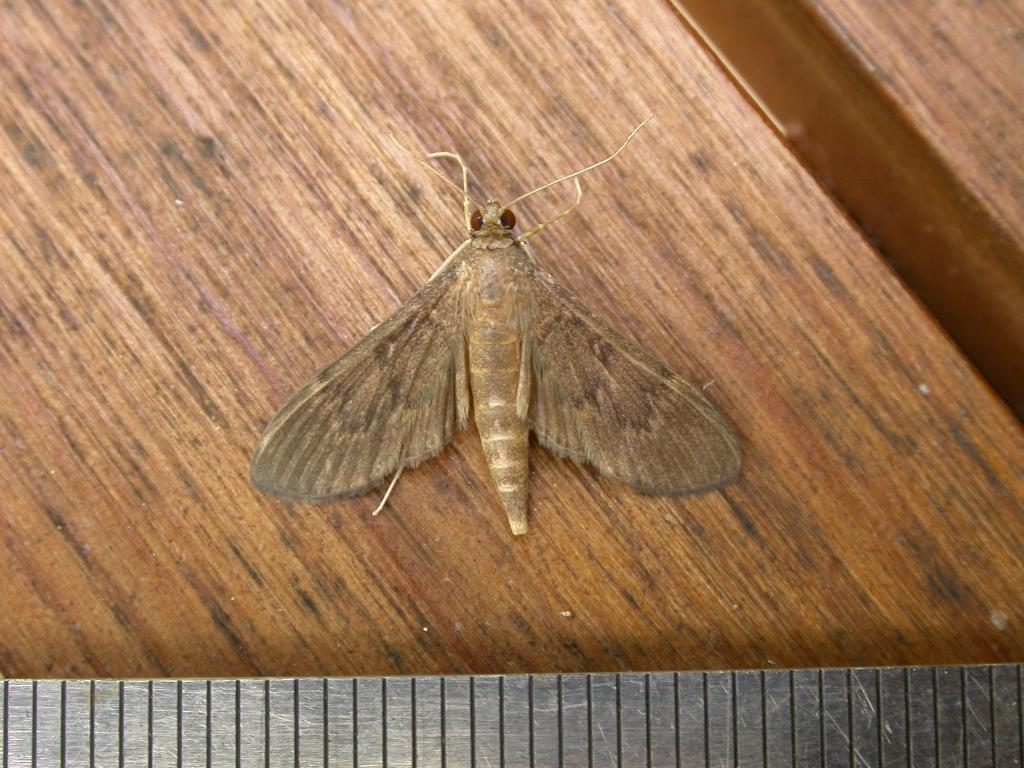What is on the wooden board in the image? There is a fly on a wooden board in the image. What can be seen at the bottom of the image? There is a scale at the bottom of the image. What type of produce is being weighed on the scale in the image? There is no produce visible in the image; only a fly on a wooden board and a scale are present. How long has the fly been stretching on the wooden board in the image? The image does not provide information about the duration of the fly's presence on the wooden board, nor does it show the fly stretching. 